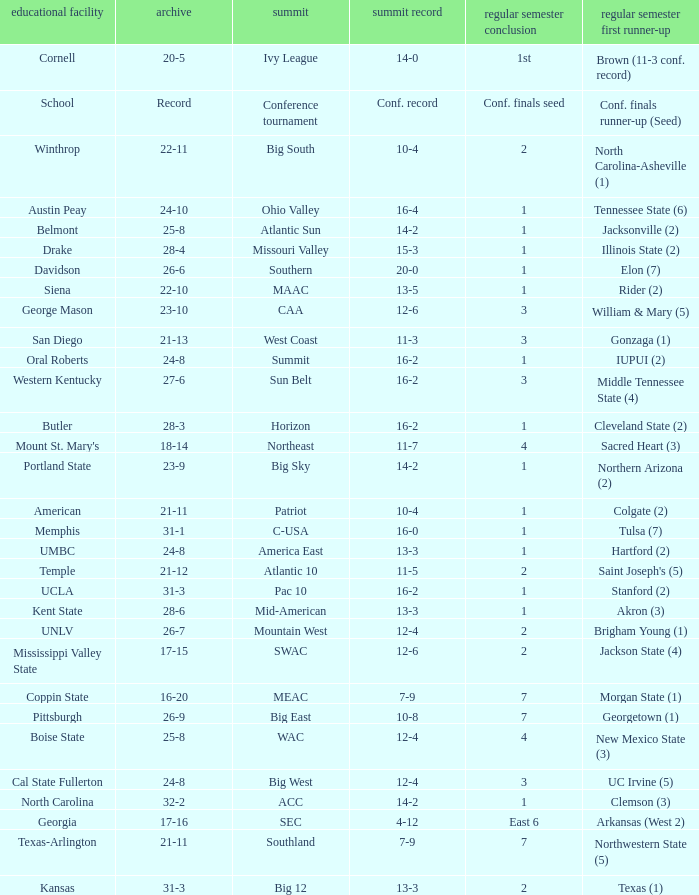Help me parse the entirety of this table. {'header': ['educational facility', 'archive', 'summit', 'summit record', 'regular semester conclusion', 'regular semester first runner-up'], 'rows': [['Cornell', '20-5', 'Ivy League', '14-0', '1st', 'Brown (11-3 conf. record)'], ['School', 'Record', 'Conference tournament', 'Conf. record', 'Conf. finals seed', 'Conf. finals runner-up (Seed)'], ['Winthrop', '22-11', 'Big South', '10-4', '2', 'North Carolina-Asheville (1)'], ['Austin Peay', '24-10', 'Ohio Valley', '16-4', '1', 'Tennessee State (6)'], ['Belmont', '25-8', 'Atlantic Sun', '14-2', '1', 'Jacksonville (2)'], ['Drake', '28-4', 'Missouri Valley', '15-3', '1', 'Illinois State (2)'], ['Davidson', '26-6', 'Southern', '20-0', '1', 'Elon (7)'], ['Siena', '22-10', 'MAAC', '13-5', '1', 'Rider (2)'], ['George Mason', '23-10', 'CAA', '12-6', '3', 'William & Mary (5)'], ['San Diego', '21-13', 'West Coast', '11-3', '3', 'Gonzaga (1)'], ['Oral Roberts', '24-8', 'Summit', '16-2', '1', 'IUPUI (2)'], ['Western Kentucky', '27-6', 'Sun Belt', '16-2', '3', 'Middle Tennessee State (4)'], ['Butler', '28-3', 'Horizon', '16-2', '1', 'Cleveland State (2)'], ["Mount St. Mary's", '18-14', 'Northeast', '11-7', '4', 'Sacred Heart (3)'], ['Portland State', '23-9', 'Big Sky', '14-2', '1', 'Northern Arizona (2)'], ['American', '21-11', 'Patriot', '10-4', '1', 'Colgate (2)'], ['Memphis', '31-1', 'C-USA', '16-0', '1', 'Tulsa (7)'], ['UMBC', '24-8', 'America East', '13-3', '1', 'Hartford (2)'], ['Temple', '21-12', 'Atlantic 10', '11-5', '2', "Saint Joseph's (5)"], ['UCLA', '31-3', 'Pac 10', '16-2', '1', 'Stanford (2)'], ['Kent State', '28-6', 'Mid-American', '13-3', '1', 'Akron (3)'], ['UNLV', '26-7', 'Mountain West', '12-4', '2', 'Brigham Young (1)'], ['Mississippi Valley State', '17-15', 'SWAC', '12-6', '2', 'Jackson State (4)'], ['Coppin State', '16-20', 'MEAC', '7-9', '7', 'Morgan State (1)'], ['Pittsburgh', '26-9', 'Big East', '10-8', '7', 'Georgetown (1)'], ['Boise State', '25-8', 'WAC', '12-4', '4', 'New Mexico State (3)'], ['Cal State Fullerton', '24-8', 'Big West', '12-4', '3', 'UC Irvine (5)'], ['North Carolina', '32-2', 'ACC', '14-2', '1', 'Clemson (3)'], ['Georgia', '17-16', 'SEC', '4-12', 'East 6', 'Arkansas (West 2)'], ['Texas-Arlington', '21-11', 'Southland', '7-9', '7', 'Northwestern State (5)'], ['Kansas', '31-3', 'Big 12', '13-3', '2', 'Texas (1)']]} Which conference is Belmont in? Atlantic Sun. 